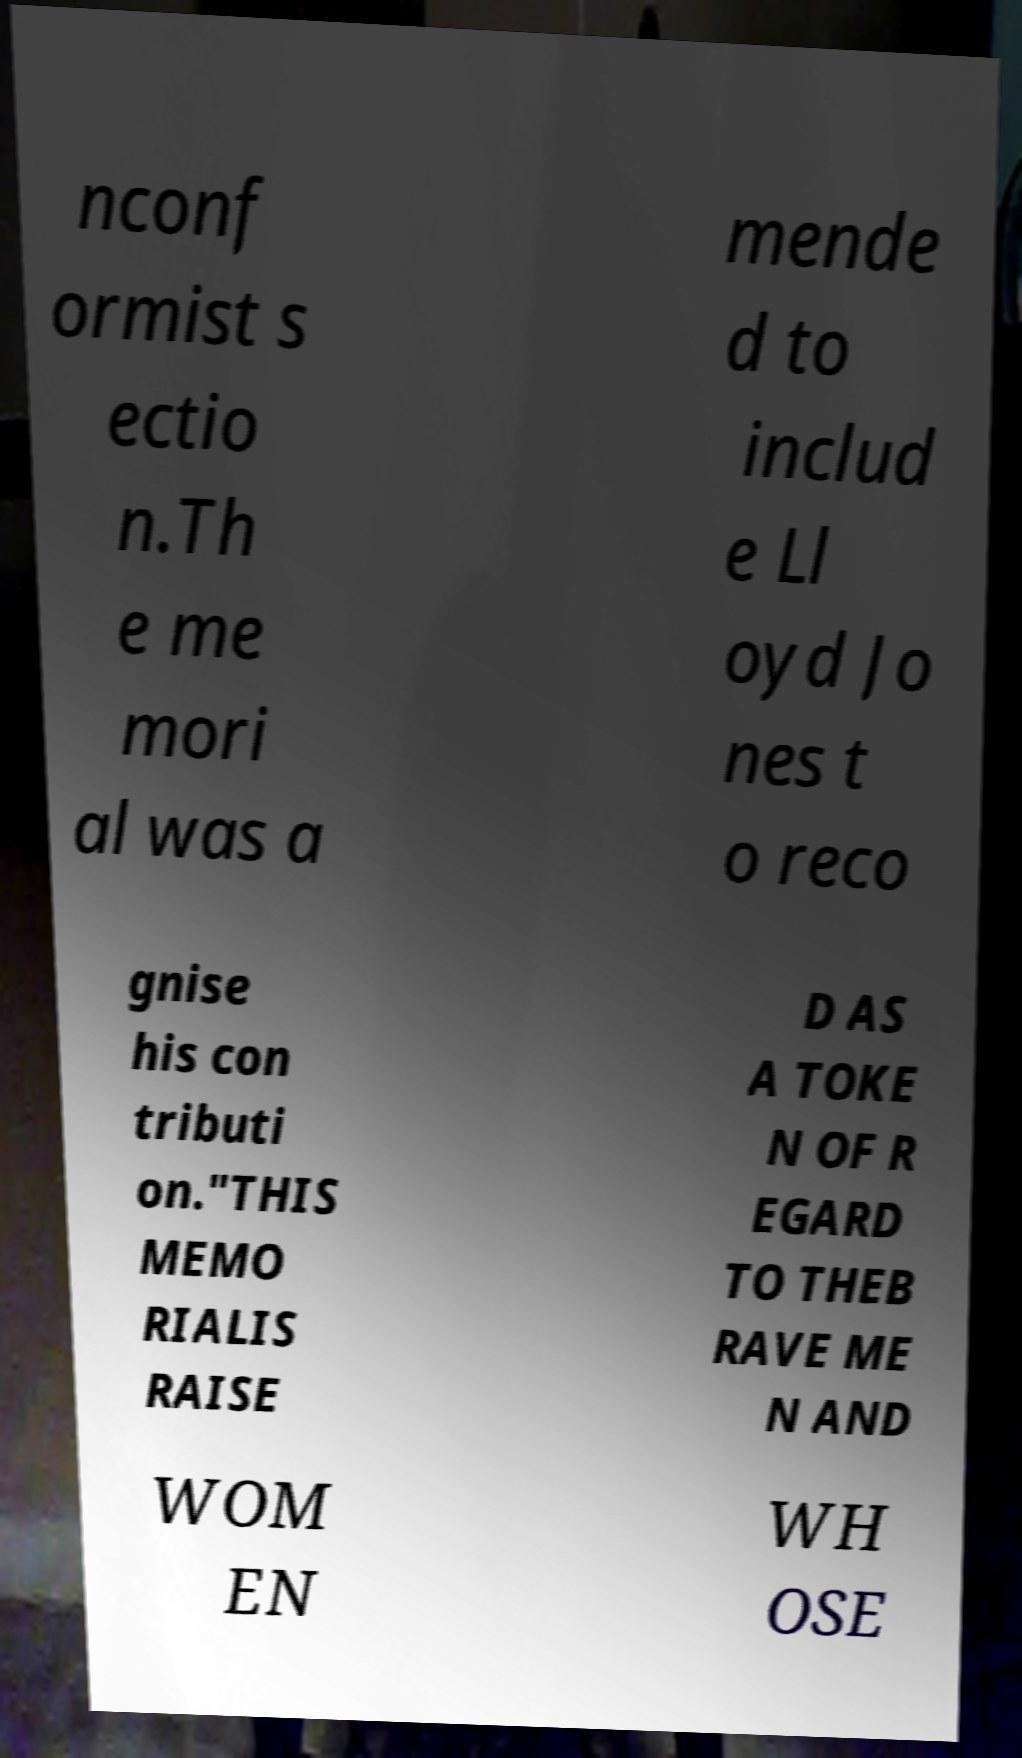There's text embedded in this image that I need extracted. Can you transcribe it verbatim? nconf ormist s ectio n.Th e me mori al was a mende d to includ e Ll oyd Jo nes t o reco gnise his con tributi on."THIS MEMO RIALIS RAISE D AS A TOKE N OF R EGARD TO THEB RAVE ME N AND WOM EN WH OSE 